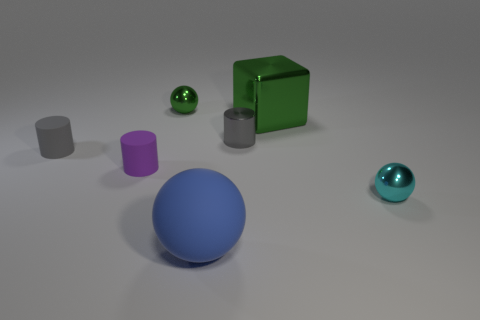The matte ball has what color?
Your answer should be very brief. Blue. What size is the cube that is the same material as the cyan thing?
Make the answer very short. Large. How many shiny objects are in front of the small cylinder that is in front of the matte object behind the small purple cylinder?
Provide a short and direct response. 1. Is the color of the large block the same as the tiny sphere that is on the left side of the tiny cyan thing?
Your answer should be compact. Yes. There is a tiny object that is the same color as the big shiny block; what shape is it?
Provide a short and direct response. Sphere. The small sphere in front of the tiny sphere that is behind the tiny sphere that is in front of the tiny gray rubber cylinder is made of what material?
Make the answer very short. Metal. Does the large object that is in front of the tiny gray matte object have the same shape as the tiny green thing?
Provide a succinct answer. Yes. There is a green object on the left side of the large blue object; what is it made of?
Your response must be concise. Metal. What number of rubber things are either small purple cylinders or cylinders?
Your answer should be compact. 2. Is there a sphere of the same size as the block?
Offer a very short reply. Yes. 